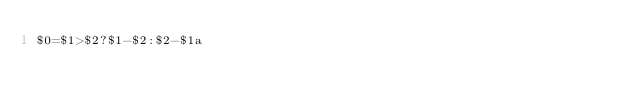<code> <loc_0><loc_0><loc_500><loc_500><_Awk_>$0=$1>$2?$1-$2:$2-$1a</code> 